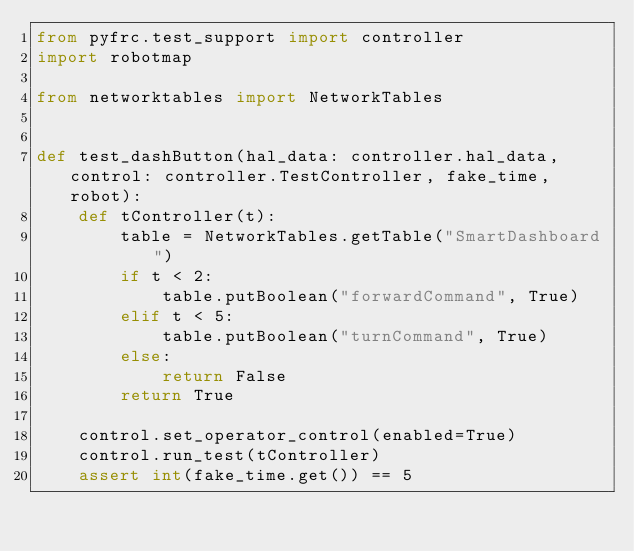<code> <loc_0><loc_0><loc_500><loc_500><_Python_>from pyfrc.test_support import controller
import robotmap

from networktables import NetworkTables


def test_dashButton(hal_data: controller.hal_data, control: controller.TestController, fake_time, robot):
    def tController(t):
        table = NetworkTables.getTable("SmartDashboard")
        if t < 2:
            table.putBoolean("forwardCommand", True)
        elif t < 5:
            table.putBoolean("turnCommand", True)
        else:
            return False
        return True

    control.set_operator_control(enabled=True)
    control.run_test(tController)
    assert int(fake_time.get()) == 5
</code> 